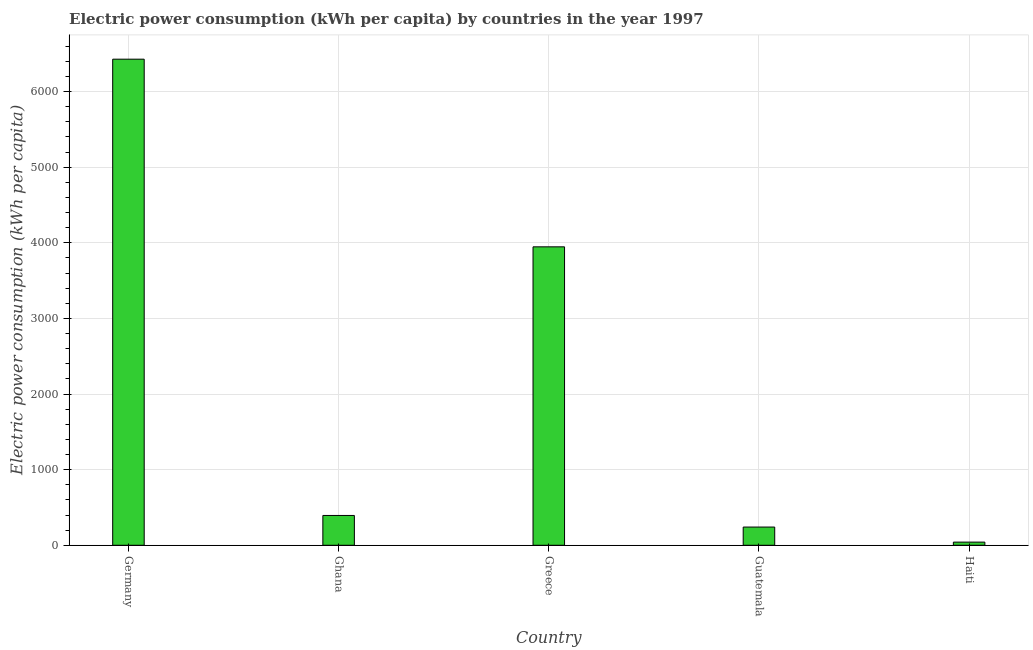Does the graph contain grids?
Your answer should be compact. Yes. What is the title of the graph?
Your answer should be compact. Electric power consumption (kWh per capita) by countries in the year 1997. What is the label or title of the Y-axis?
Make the answer very short. Electric power consumption (kWh per capita). What is the electric power consumption in Germany?
Give a very brief answer. 6427.8. Across all countries, what is the maximum electric power consumption?
Your answer should be compact. 6427.8. Across all countries, what is the minimum electric power consumption?
Make the answer very short. 41.67. In which country was the electric power consumption minimum?
Your answer should be compact. Haiti. What is the sum of the electric power consumption?
Your answer should be compact. 1.11e+04. What is the difference between the electric power consumption in Germany and Greece?
Give a very brief answer. 2481.34. What is the average electric power consumption per country?
Keep it short and to the point. 2210.22. What is the median electric power consumption?
Offer a terse response. 394.28. What is the ratio of the electric power consumption in Germany to that in Ghana?
Your answer should be very brief. 16.3. Is the electric power consumption in Germany less than that in Guatemala?
Your answer should be compact. No. Is the difference between the electric power consumption in Guatemala and Haiti greater than the difference between any two countries?
Keep it short and to the point. No. What is the difference between the highest and the second highest electric power consumption?
Your answer should be compact. 2481.34. Is the sum of the electric power consumption in Germany and Greece greater than the maximum electric power consumption across all countries?
Offer a very short reply. Yes. What is the difference between the highest and the lowest electric power consumption?
Give a very brief answer. 6386.13. In how many countries, is the electric power consumption greater than the average electric power consumption taken over all countries?
Offer a terse response. 2. How many bars are there?
Provide a short and direct response. 5. Are all the bars in the graph horizontal?
Give a very brief answer. No. How many countries are there in the graph?
Your response must be concise. 5. Are the values on the major ticks of Y-axis written in scientific E-notation?
Give a very brief answer. No. What is the Electric power consumption (kWh per capita) of Germany?
Your response must be concise. 6427.8. What is the Electric power consumption (kWh per capita) of Ghana?
Offer a very short reply. 394.28. What is the Electric power consumption (kWh per capita) in Greece?
Your response must be concise. 3946.46. What is the Electric power consumption (kWh per capita) in Guatemala?
Your answer should be very brief. 240.9. What is the Electric power consumption (kWh per capita) in Haiti?
Offer a terse response. 41.67. What is the difference between the Electric power consumption (kWh per capita) in Germany and Ghana?
Your response must be concise. 6033.52. What is the difference between the Electric power consumption (kWh per capita) in Germany and Greece?
Give a very brief answer. 2481.34. What is the difference between the Electric power consumption (kWh per capita) in Germany and Guatemala?
Make the answer very short. 6186.9. What is the difference between the Electric power consumption (kWh per capita) in Germany and Haiti?
Your response must be concise. 6386.13. What is the difference between the Electric power consumption (kWh per capita) in Ghana and Greece?
Provide a succinct answer. -3552.17. What is the difference between the Electric power consumption (kWh per capita) in Ghana and Guatemala?
Provide a succinct answer. 153.38. What is the difference between the Electric power consumption (kWh per capita) in Ghana and Haiti?
Make the answer very short. 352.62. What is the difference between the Electric power consumption (kWh per capita) in Greece and Guatemala?
Offer a very short reply. 3705.56. What is the difference between the Electric power consumption (kWh per capita) in Greece and Haiti?
Offer a terse response. 3904.79. What is the difference between the Electric power consumption (kWh per capita) in Guatemala and Haiti?
Your answer should be compact. 199.23. What is the ratio of the Electric power consumption (kWh per capita) in Germany to that in Ghana?
Offer a terse response. 16.3. What is the ratio of the Electric power consumption (kWh per capita) in Germany to that in Greece?
Your answer should be compact. 1.63. What is the ratio of the Electric power consumption (kWh per capita) in Germany to that in Guatemala?
Keep it short and to the point. 26.68. What is the ratio of the Electric power consumption (kWh per capita) in Germany to that in Haiti?
Offer a terse response. 154.27. What is the ratio of the Electric power consumption (kWh per capita) in Ghana to that in Guatemala?
Your answer should be very brief. 1.64. What is the ratio of the Electric power consumption (kWh per capita) in Ghana to that in Haiti?
Provide a succinct answer. 9.46. What is the ratio of the Electric power consumption (kWh per capita) in Greece to that in Guatemala?
Keep it short and to the point. 16.38. What is the ratio of the Electric power consumption (kWh per capita) in Greece to that in Haiti?
Ensure brevity in your answer.  94.71. What is the ratio of the Electric power consumption (kWh per capita) in Guatemala to that in Haiti?
Provide a short and direct response. 5.78. 